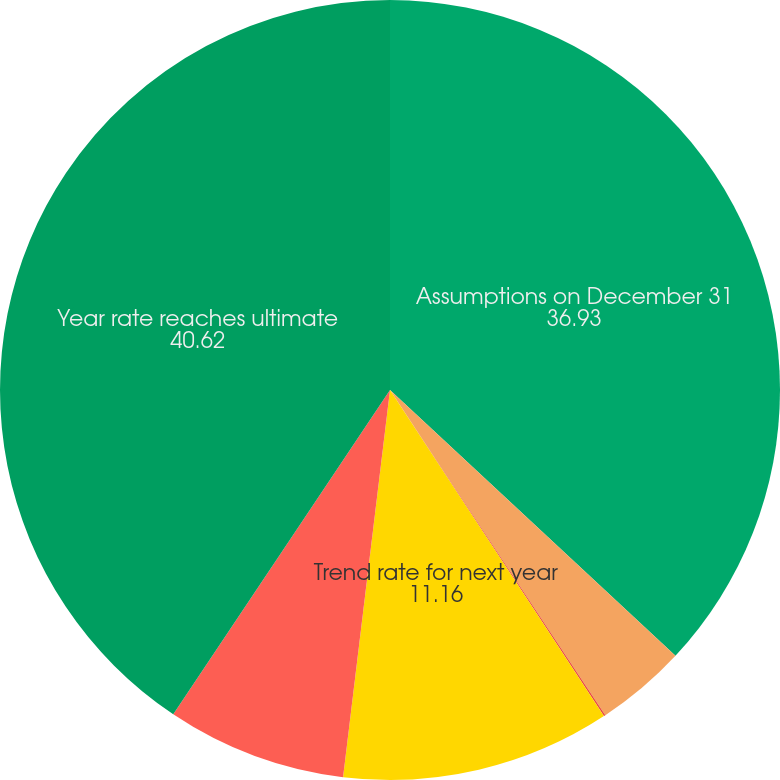Convert chart. <chart><loc_0><loc_0><loc_500><loc_500><pie_chart><fcel>Assumptions on December 31<fcel>Discount rate<fcel>Rate of increase in<fcel>Trend rate for next year<fcel>Ultimate trend rate<fcel>Year rate reaches ultimate<nl><fcel>36.93%<fcel>3.76%<fcel>0.07%<fcel>11.16%<fcel>7.46%<fcel>40.62%<nl></chart> 